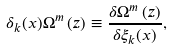<formula> <loc_0><loc_0><loc_500><loc_500>\delta _ { k } ( x ) \Omega ^ { m } \left ( z \right ) \equiv \frac { \delta \Omega ^ { m } \left ( z \right ) } { \delta \xi _ { k } ( x ) } ,</formula> 